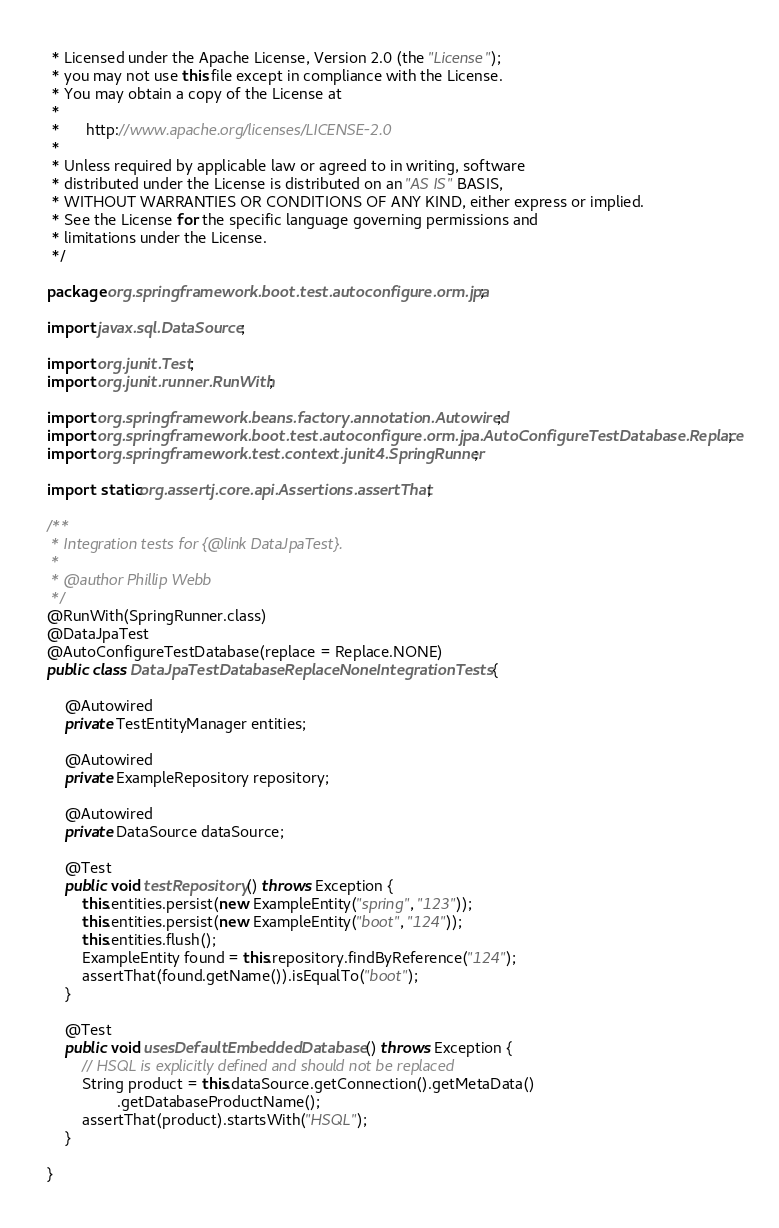<code> <loc_0><loc_0><loc_500><loc_500><_Java_> * Licensed under the Apache License, Version 2.0 (the "License");
 * you may not use this file except in compliance with the License.
 * You may obtain a copy of the License at
 *
 *      http://www.apache.org/licenses/LICENSE-2.0
 *
 * Unless required by applicable law or agreed to in writing, software
 * distributed under the License is distributed on an "AS IS" BASIS,
 * WITHOUT WARRANTIES OR CONDITIONS OF ANY KIND, either express or implied.
 * See the License for the specific language governing permissions and
 * limitations under the License.
 */

package org.springframework.boot.test.autoconfigure.orm.jpa;

import javax.sql.DataSource;

import org.junit.Test;
import org.junit.runner.RunWith;

import org.springframework.beans.factory.annotation.Autowired;
import org.springframework.boot.test.autoconfigure.orm.jpa.AutoConfigureTestDatabase.Replace;
import org.springframework.test.context.junit4.SpringRunner;

import static org.assertj.core.api.Assertions.assertThat;

/**
 * Integration tests for {@link DataJpaTest}.
 *
 * @author Phillip Webb
 */
@RunWith(SpringRunner.class)
@DataJpaTest
@AutoConfigureTestDatabase(replace = Replace.NONE)
public class DataJpaTestDatabaseReplaceNoneIntegrationTests {

	@Autowired
	private TestEntityManager entities;

	@Autowired
	private ExampleRepository repository;

	@Autowired
	private DataSource dataSource;

	@Test
	public void testRepository() throws Exception {
		this.entities.persist(new ExampleEntity("spring", "123"));
		this.entities.persist(new ExampleEntity("boot", "124"));
		this.entities.flush();
		ExampleEntity found = this.repository.findByReference("124");
		assertThat(found.getName()).isEqualTo("boot");
	}

	@Test
	public void usesDefaultEmbeddedDatabase() throws Exception {
		// HSQL is explicitly defined and should not be replaced
		String product = this.dataSource.getConnection().getMetaData()
				.getDatabaseProductName();
		assertThat(product).startsWith("HSQL");
	}

}
</code> 